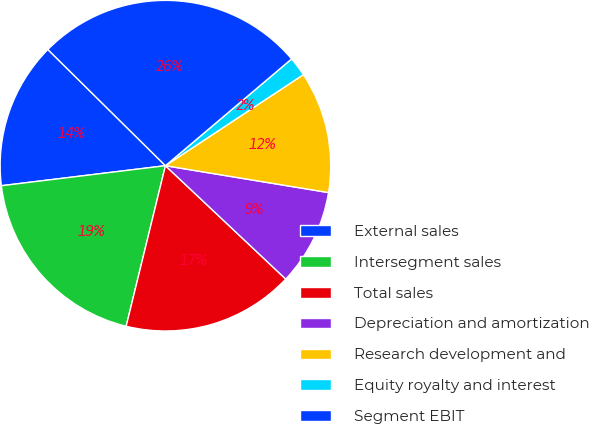<chart> <loc_0><loc_0><loc_500><loc_500><pie_chart><fcel>External sales<fcel>Intersegment sales<fcel>Total sales<fcel>Depreciation and amortization<fcel>Research development and<fcel>Equity royalty and interest<fcel>Segment EBIT<nl><fcel>14.34%<fcel>19.25%<fcel>16.79%<fcel>9.43%<fcel>11.89%<fcel>1.89%<fcel>26.42%<nl></chart> 